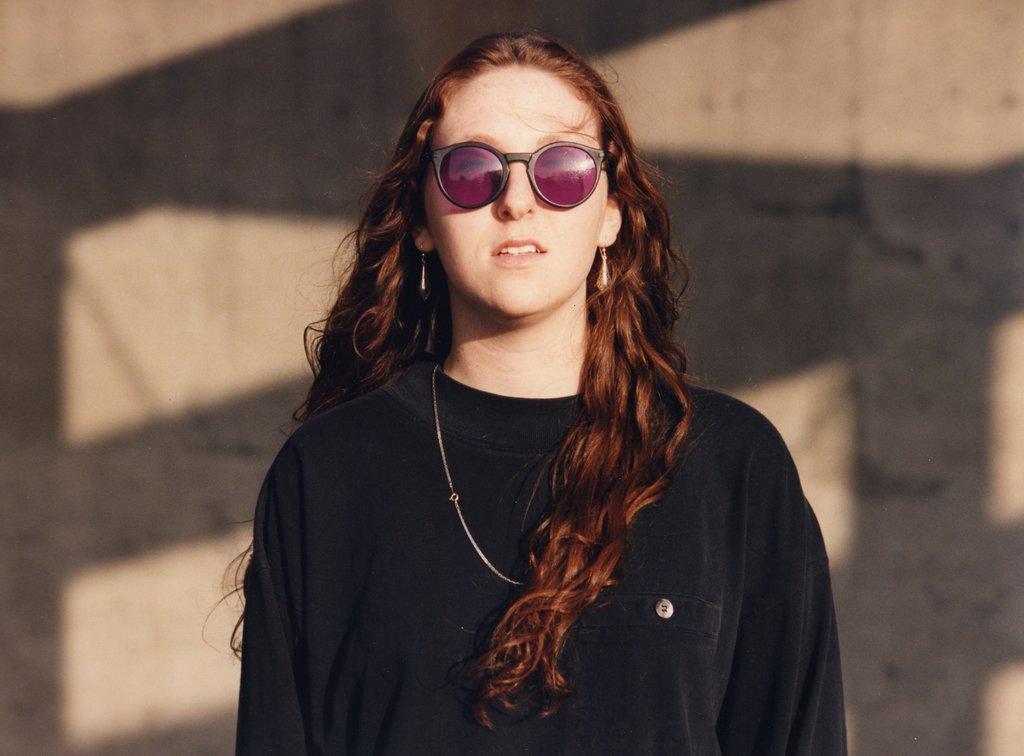Please provide a concise description of this image. Here in this picture we can see a woman in a black colored t shirt present over there and we can say she is wearing goggles on her hand behind her we can see shadows on the wall present over there. 